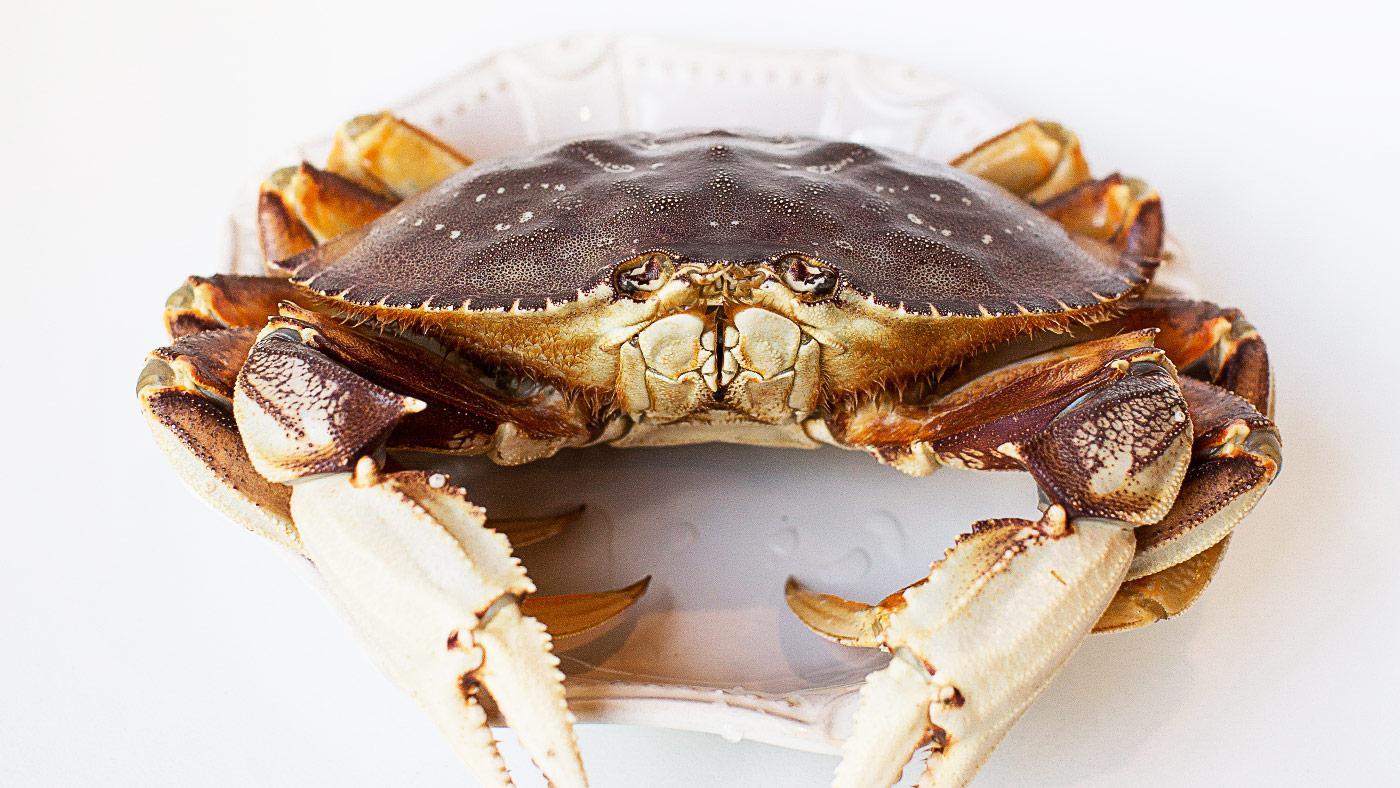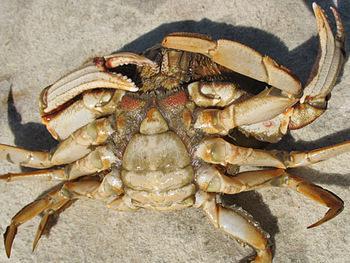The first image is the image on the left, the second image is the image on the right. Examine the images to the left and right. Is the description "Several cooked crabs sit together in at least one of the images." accurate? Answer yes or no. No. The first image is the image on the left, the second image is the image on the right. For the images displayed, is the sentence "There are exactly two crabs." factually correct? Answer yes or no. Yes. 